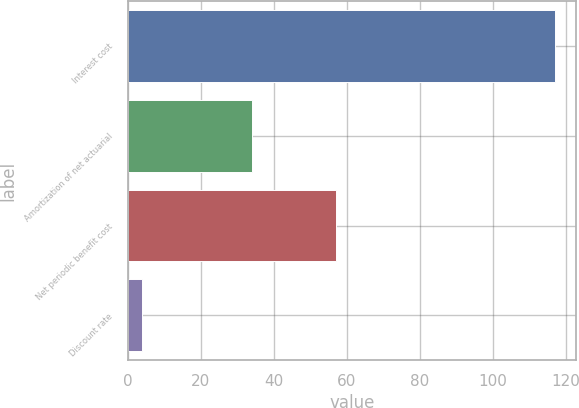Convert chart. <chart><loc_0><loc_0><loc_500><loc_500><bar_chart><fcel>Interest cost<fcel>Amortization of net actuarial<fcel>Net periodic benefit cost<fcel>Discount rate<nl><fcel>117<fcel>34<fcel>57<fcel>4.01<nl></chart> 